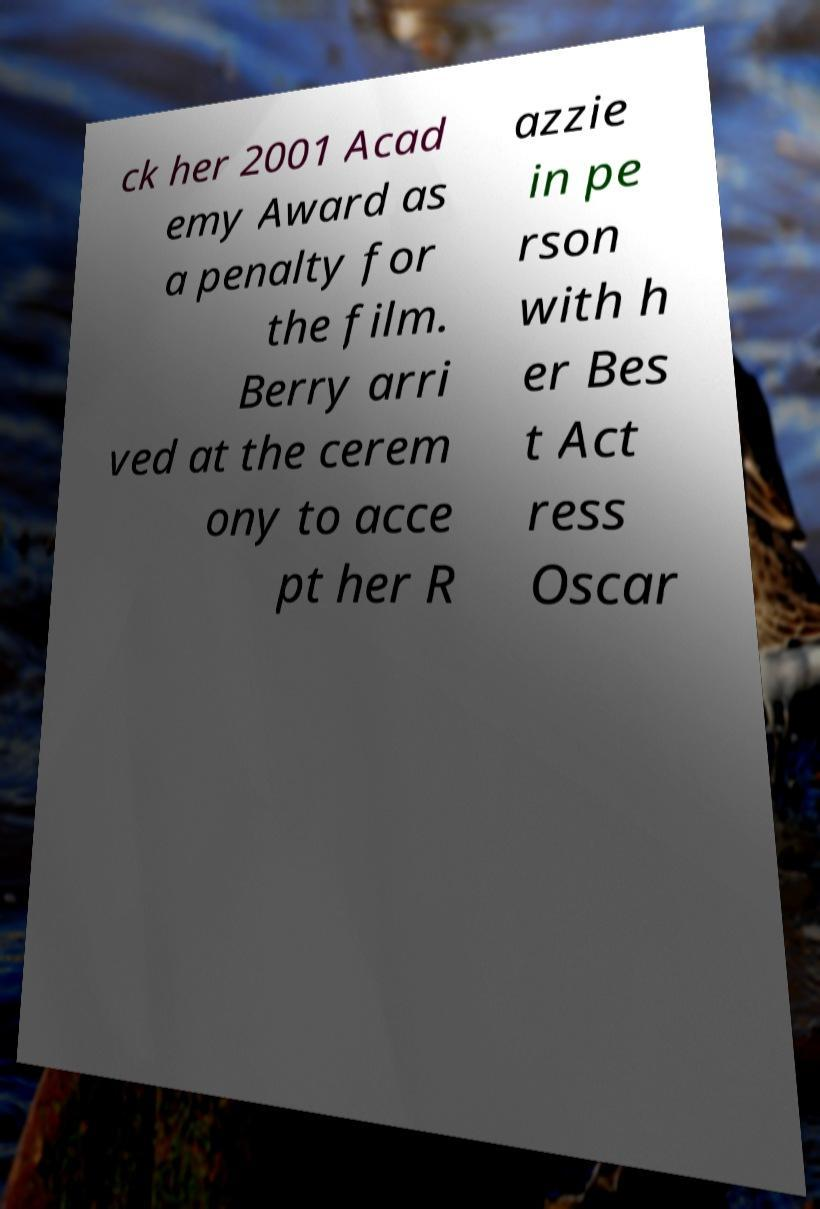Please identify and transcribe the text found in this image. ck her 2001 Acad emy Award as a penalty for the film. Berry arri ved at the cerem ony to acce pt her R azzie in pe rson with h er Bes t Act ress Oscar 